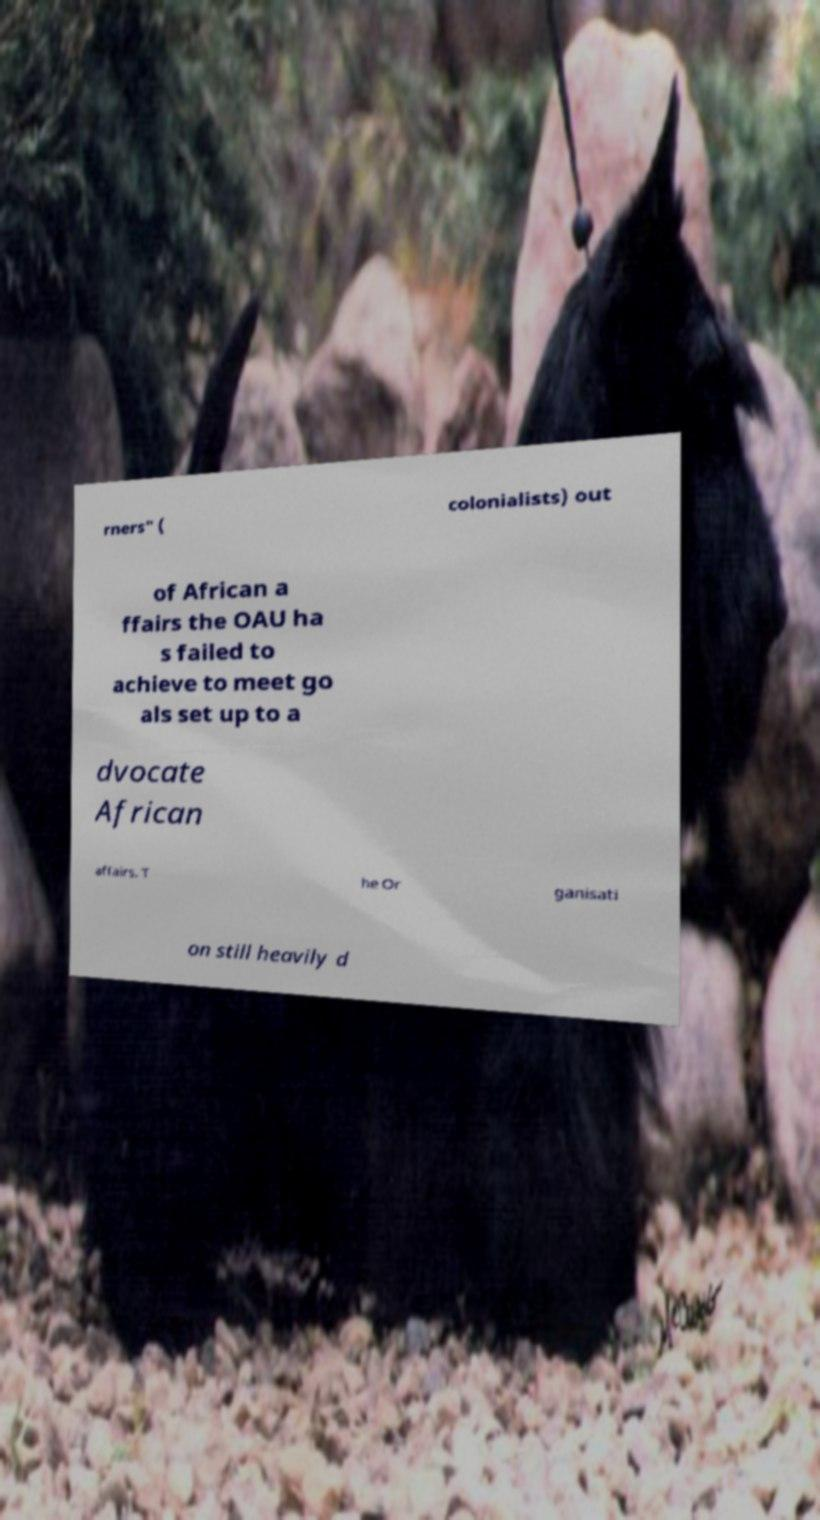I need the written content from this picture converted into text. Can you do that? rners" ( colonialists) out of African a ffairs the OAU ha s failed to achieve to meet go als set up to a dvocate African affairs. T he Or ganisati on still heavily d 